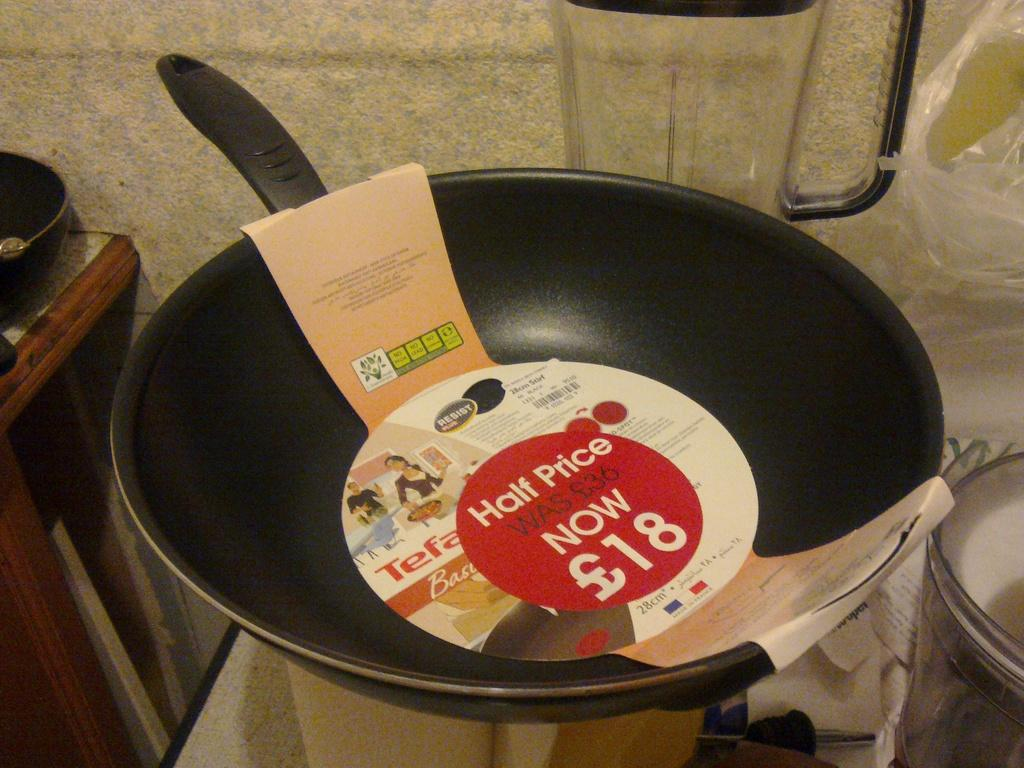Provide a one-sentence caption for the provided image. The discount on this pan is 50 percent off normal price. 